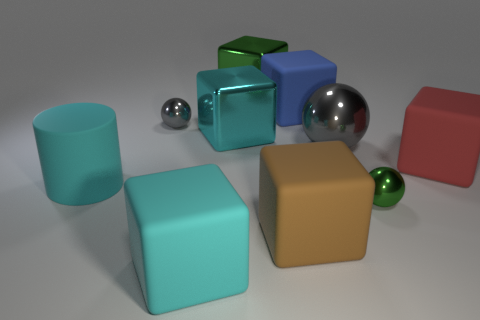What is the material of the other sphere that is the same color as the big shiny ball?
Keep it short and to the point. Metal. What is the size of the metallic block that is the same color as the cylinder?
Your answer should be compact. Large. What number of metallic objects have the same color as the large cylinder?
Give a very brief answer. 1. Are there any cyan objects that have the same size as the brown block?
Keep it short and to the point. Yes. What number of objects are rubber cubes that are right of the brown object or big cyan shiny things?
Make the answer very short. 3. Do the small green ball and the green thing that is behind the small gray ball have the same material?
Keep it short and to the point. Yes. How many other objects are there of the same shape as the big green thing?
Keep it short and to the point. 5. What number of objects are either large objects in front of the cyan metallic object or cyan objects that are behind the large gray ball?
Provide a short and direct response. 6. What number of other things are there of the same color as the big matte cylinder?
Offer a very short reply. 2. Are there fewer big cyan cylinders behind the big cyan metallic thing than gray shiny spheres that are right of the green cube?
Ensure brevity in your answer.  Yes. 